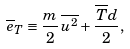Convert formula to latex. <formula><loc_0><loc_0><loc_500><loc_500>\overline { e } _ { T } \equiv \frac { m } { 2 } \, \overline { u ^ { 2 } } + \frac { \overline { T } d } { 2 } ,</formula> 